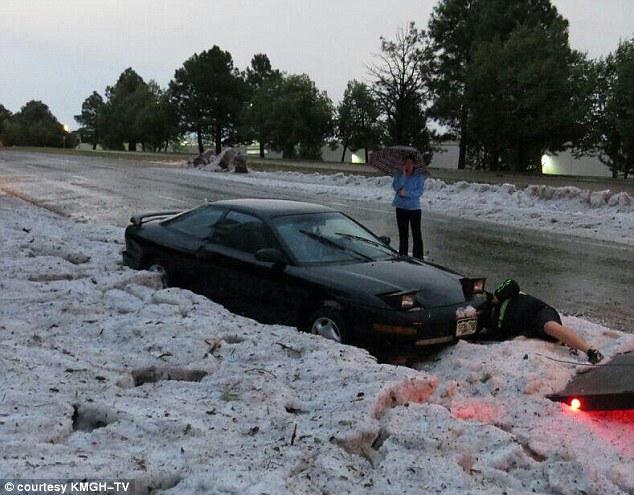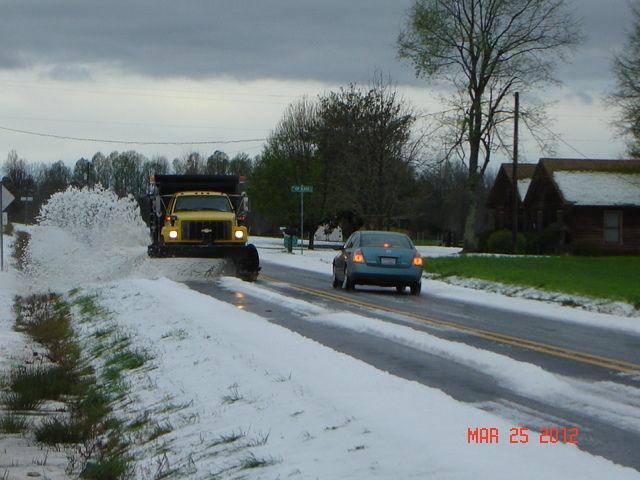The first image is the image on the left, the second image is the image on the right. For the images shown, is this caption "In the right image a snow plow is plowing snow." true? Answer yes or no. Yes. 